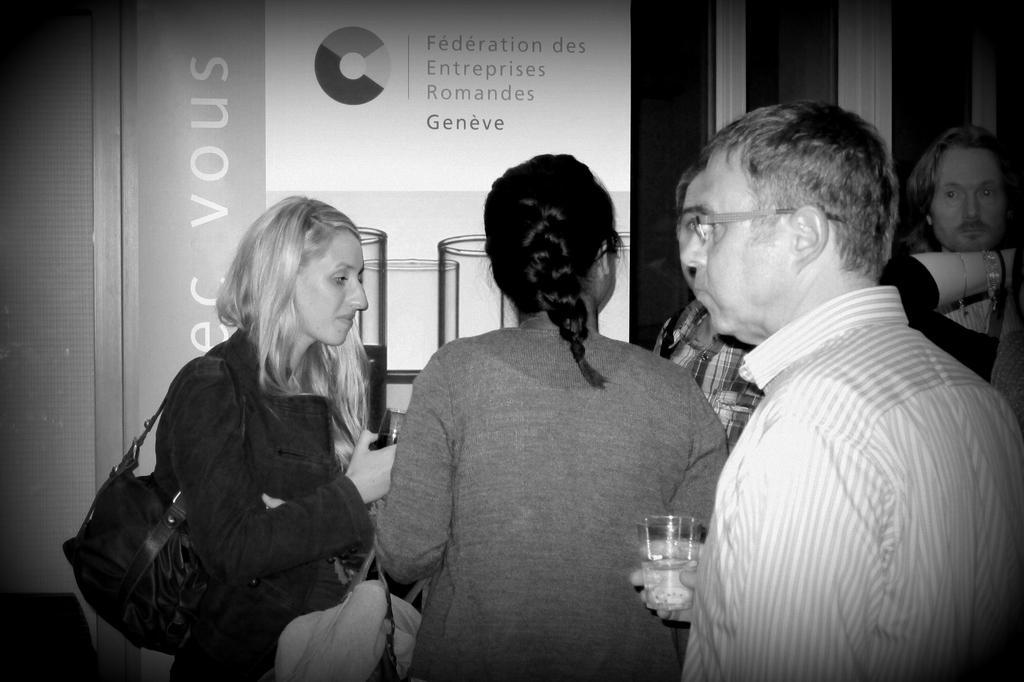Please provide a concise description of this image. In this image there are group of persons standing. In the front there is a man standing and holding a glass in his hand. On the left side there is a woman standing and holding a glass in her hand and in the background there is a board with some text written on it and there is an object which is white in colour. 